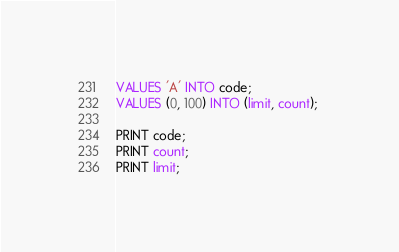<code> <loc_0><loc_0><loc_500><loc_500><_SQL_>VALUES 'A' INTO code;
VALUES (0, 100) INTO (limit, count); 

PRINT code;
PRINT count;
PRINT limit;</code> 